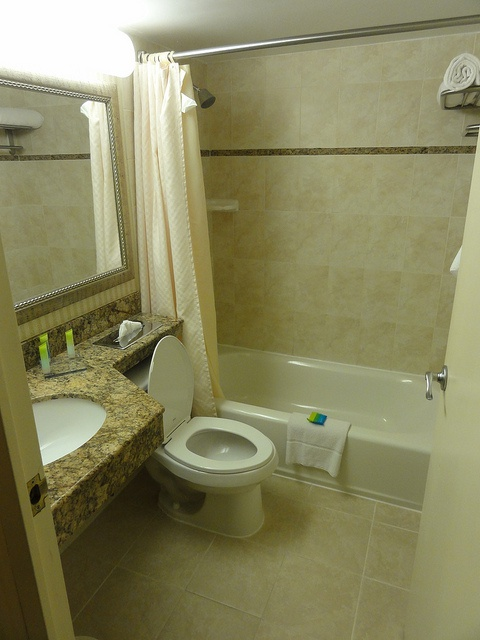Describe the objects in this image and their specific colors. I can see toilet in white, olive, darkgreen, and black tones, sink in white, darkgray, beige, and olive tones, bottle in white and olive tones, and bottle in white, olive, khaki, and darkgray tones in this image. 